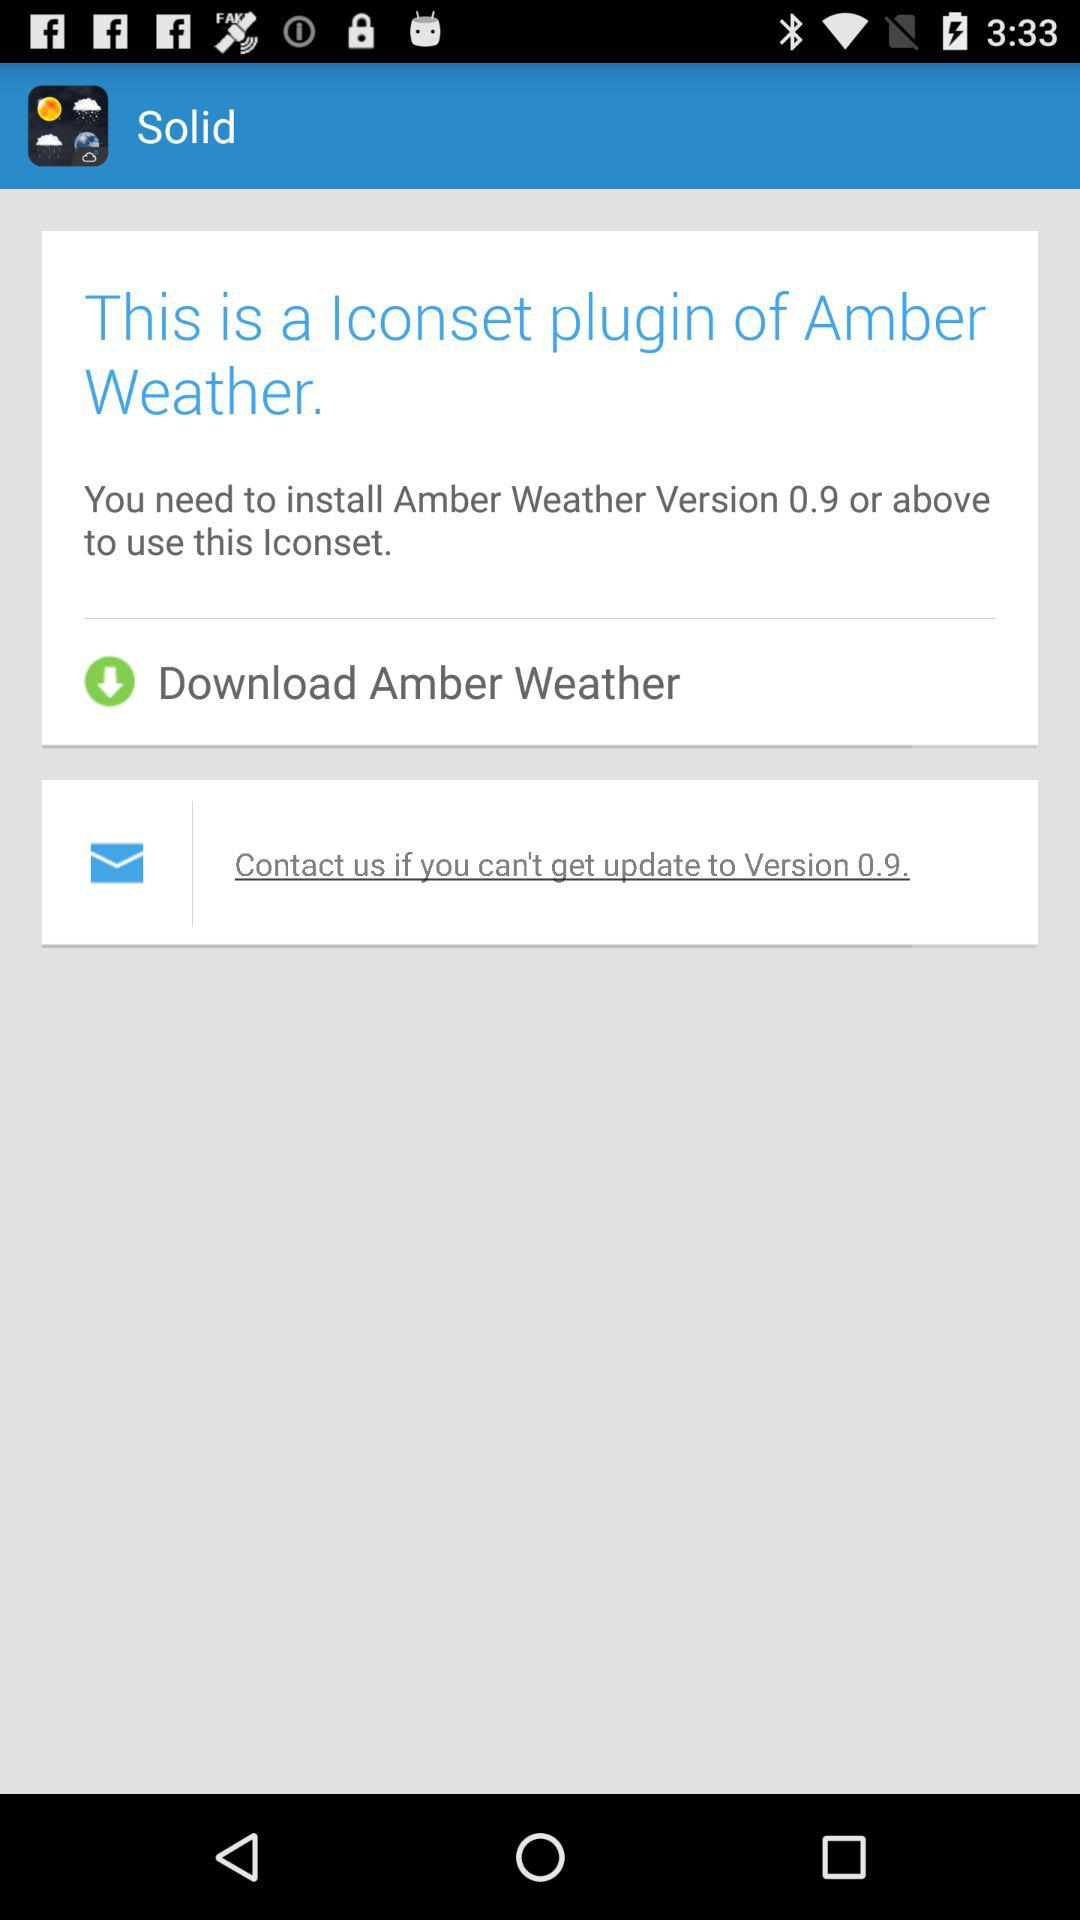What version is shown? The shown version is 0.9. 